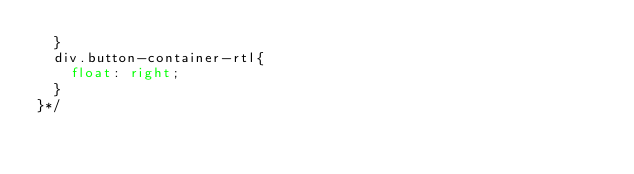Convert code to text. <code><loc_0><loc_0><loc_500><loc_500><_CSS_>  }
  div.button-container-rtl{
    float: right;
  }
}*/
</code> 